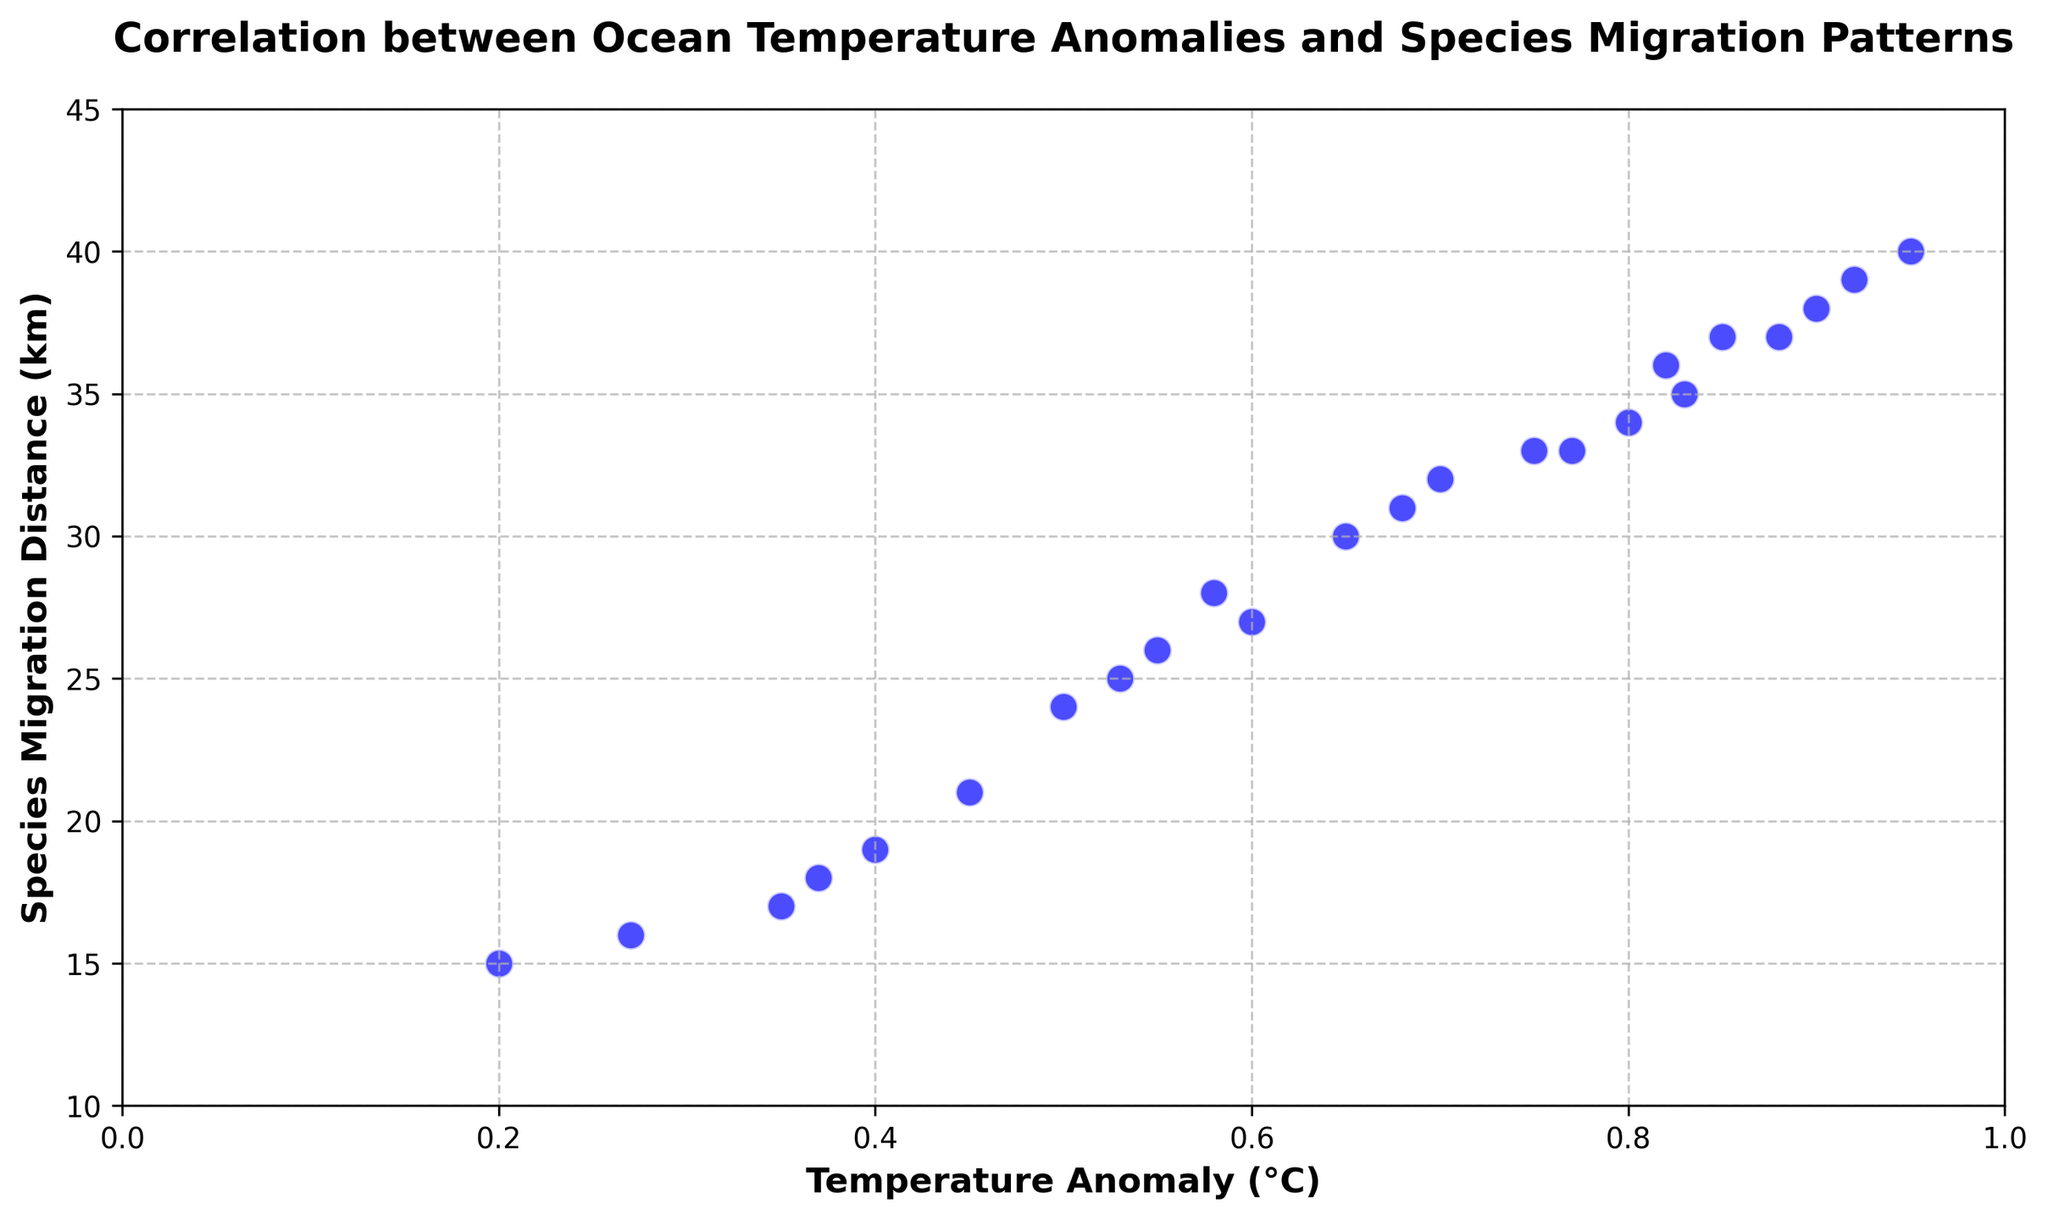Which year shows the highest species migration distance on the scatter plot? By looking at the figure, find the data point that is furthest on the y-axis. The highest species migration distance is 40 km, which occurs in the year 2023.
Answer: 2023 How has the species migration distance changed over the years as ocean temperature anomalies increased? Observing the scatter plot, there is an upward trend in the data points, indicating that as the temperature anomalies increased, the species migration distances also increased.
Answer: Increased What is the range of temperature anomalies shown in the figure? To find the range, identify the minimum and maximum values for temperature anomalies on the x-axis. The minimum temperature anomaly is 0.2°C, and the maximum is 0.95°C. Thus, the range is 0.95°C - 0.2°C.
Answer: 0.75°C Which year had a species migration distance of approximately 30 km? Locate the point on the y-axis corresponding to 30 km and trace it to its respective year on the x-axis. This data point is at a temperature anomaly of 0.65°C, corresponding to the year 2011.
Answer: 2011 Is there a clear visual trend between temperature anomalies and species migration distances? If so, describe it. The scatter plot shows a positive correlation trend where higher temperature anomalies correspond to greater species migration distances, indicating that species are migrating further as ocean temperatures rise.
Answer: Positive correlation What do the gridlines on the scatter plot help with? The gridlines help with readability and allow us to more easily locate and interpret specific data points by providing reference lines for both temperature anomalies and species migration distances.
Answer: Readability By how many kilometers did species migration distance increase between 2000 and 2023? Identify the migration distances for 2000 (15 km) and 2023 (40 km) and calculate the difference: 40 km - 15 km. This indicates an increase of 25 km over this period.
Answer: 25 km Which year corresponds to a temperature anomaly of 0.7°C? Locate the point on the x-axis corresponding to 0.7°C and trace it vertically to find the year. This data point corresponds to the year 2012.
Answer: 2012 What's the difference in species migration distances between the years with the lowest and highest temperature anomalies? Identify the years with the lowest (2000, 15 km) and highest (2023, 40 km) temperature anomalies and subtract the migration distances: 40 km - 15 km.
Answer: 25 km Considering the trend in the scatter plot, what might we predict about species migration distances if the temperature anomaly keeps increasing? Based on the positive correlation shown in the plot, we can predict that if the temperature anomaly keeps increasing, the species migration distances are likely to continue increasing as well.
Answer: Increase 